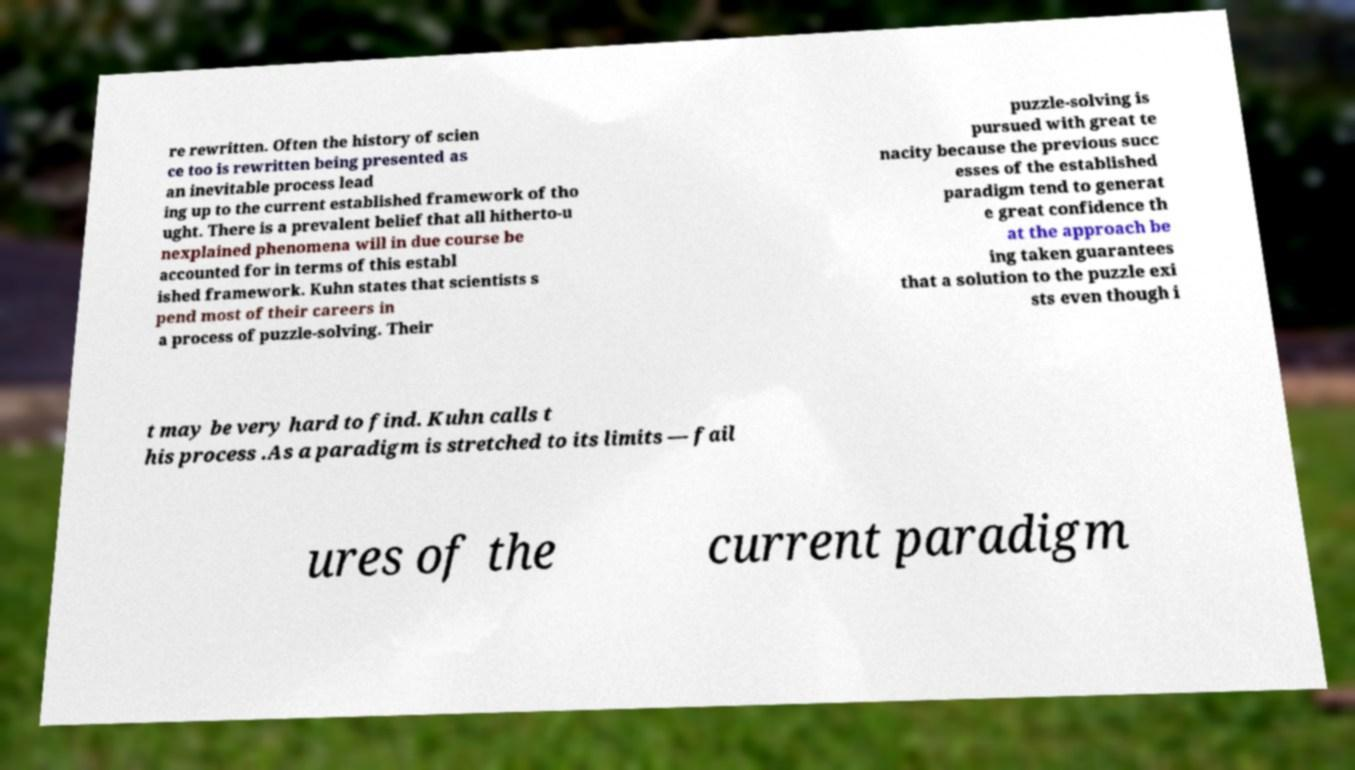For documentation purposes, I need the text within this image transcribed. Could you provide that? re rewritten. Often the history of scien ce too is rewritten being presented as an inevitable process lead ing up to the current established framework of tho ught. There is a prevalent belief that all hitherto-u nexplained phenomena will in due course be accounted for in terms of this establ ished framework. Kuhn states that scientists s pend most of their careers in a process of puzzle-solving. Their puzzle-solving is pursued with great te nacity because the previous succ esses of the established paradigm tend to generat e great confidence th at the approach be ing taken guarantees that a solution to the puzzle exi sts even though i t may be very hard to find. Kuhn calls t his process .As a paradigm is stretched to its limits — fail ures of the current paradigm 